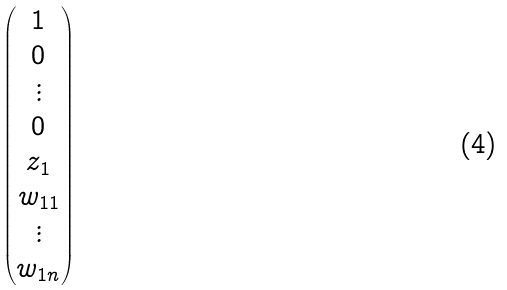<formula> <loc_0><loc_0><loc_500><loc_500>\begin{pmatrix} 1 \\ 0 \\ \vdots \\ 0 \\ z _ { 1 } \\ w _ { 1 1 } \\ \vdots \\ w _ { 1 n } \\ \end{pmatrix}</formula> 